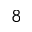Convert formula to latex. <formula><loc_0><loc_0><loc_500><loc_500>_ { 8 }</formula> 